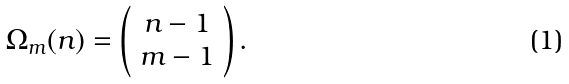Convert formula to latex. <formula><loc_0><loc_0><loc_500><loc_500>\Omega _ { m } ( n ) = \left ( \begin{array} { c c } n - 1 \\ m - 1 \end{array} \right ) .</formula> 